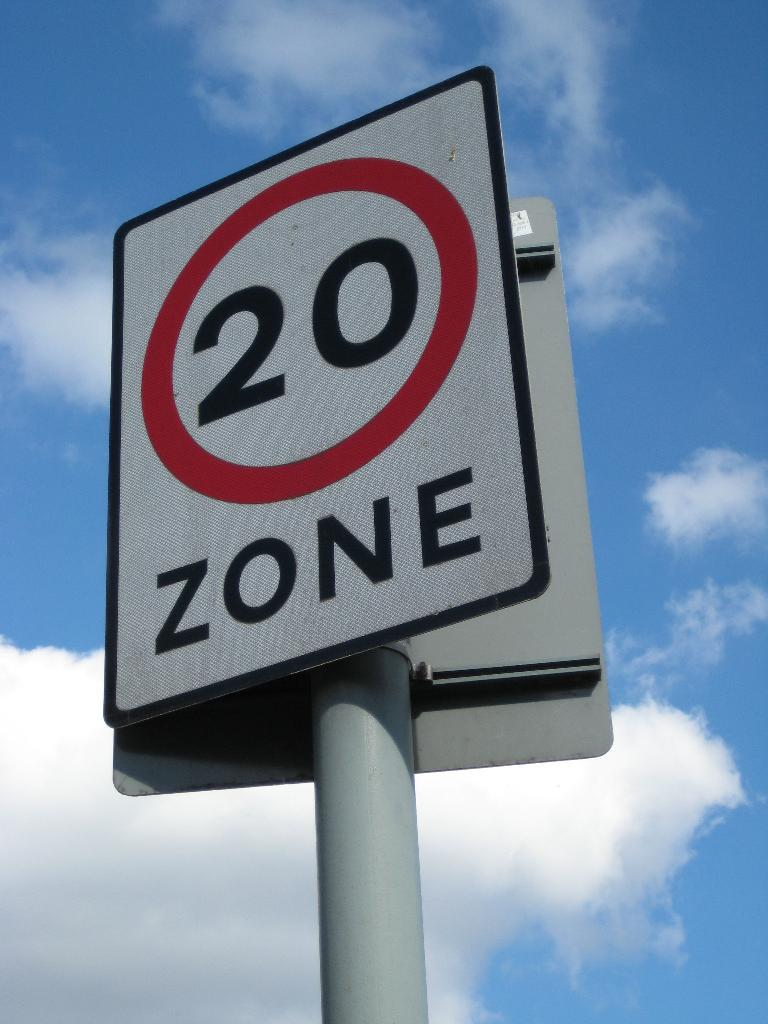What objects are attached to the pole in the image? There are boards on a pole in the image. What can be seen in the sky in the background of the image? There are clouds visible in the sky in the background of the image. Are there any giants visible in the image? No, there are no giants present in the image. What type of suit is being worn by the clouds in the background? The clouds in the background are not wearing any suits, as they are a natural atmospheric phenomenon and not human-like entities. 